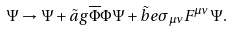<formula> <loc_0><loc_0><loc_500><loc_500>\Psi \rightarrow \Psi + \tilde { a } g \overline { \Phi } \Phi \Psi + \tilde { b } e \sigma _ { \mu \nu } F ^ { \mu \nu } \Psi .</formula> 